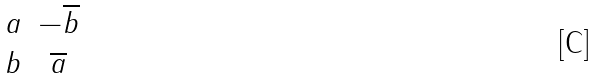<formula> <loc_0><loc_0><loc_500><loc_500>\begin{matrix} a & - \overline { b } \\ b & \overline { a } \end{matrix}</formula> 